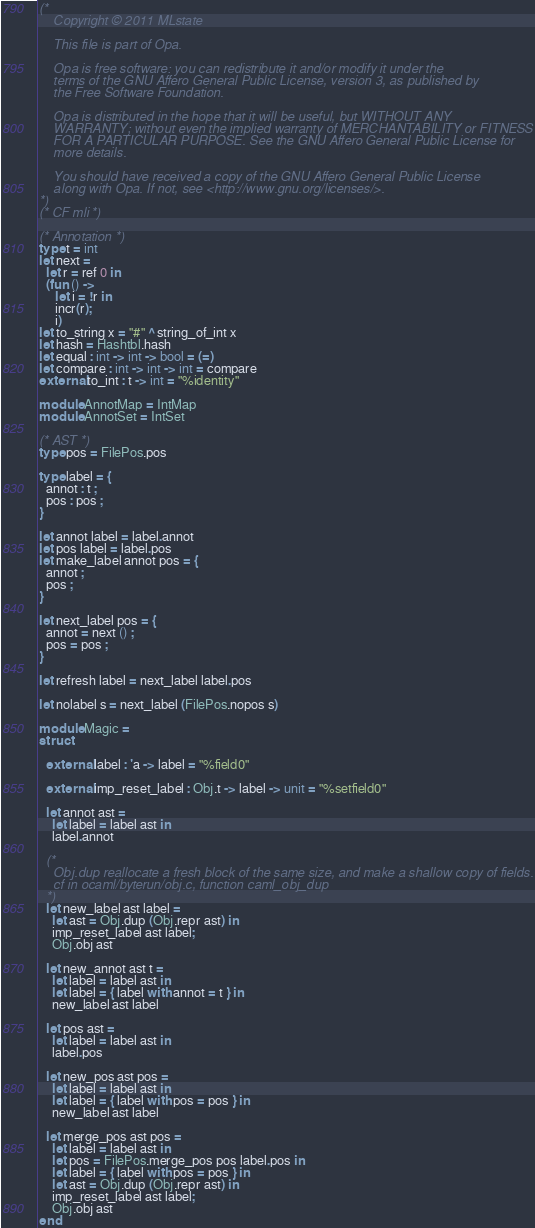<code> <loc_0><loc_0><loc_500><loc_500><_OCaml_>(*
    Copyright © 2011 MLstate

    This file is part of Opa.

    Opa is free software: you can redistribute it and/or modify it under the
    terms of the GNU Affero General Public License, version 3, as published by
    the Free Software Foundation.

    Opa is distributed in the hope that it will be useful, but WITHOUT ANY
    WARRANTY; without even the implied warranty of MERCHANTABILITY or FITNESS
    FOR A PARTICULAR PURPOSE. See the GNU Affero General Public License for
    more details.

    You should have received a copy of the GNU Affero General Public License
    along with Opa. If not, see <http://www.gnu.org/licenses/>.
*)
(* CF mli *)

(* Annotation *)
type t = int
let next =
  let r = ref 0 in
  (fun () ->
     let i = !r in
     incr(r);
     i)
let to_string x = "#" ^ string_of_int x
let hash = Hashtbl.hash
let equal : int -> int -> bool = (=)
let compare : int -> int -> int = compare
external to_int : t -> int = "%identity"

module AnnotMap = IntMap
module AnnotSet = IntSet

(* AST *)
type pos = FilePos.pos

type label = {
  annot : t ;
  pos : pos ;
}

let annot label = label.annot
let pos label = label.pos
let make_label annot pos = {
  annot ;
  pos ;
}

let next_label pos = {
  annot = next () ;
  pos = pos ;
}

let refresh label = next_label label.pos

let nolabel s = next_label (FilePos.nopos s)

module Magic =
struct

  external label : 'a -> label = "%field0"

  external imp_reset_label : Obj.t -> label -> unit = "%setfield0"

  let annot ast =
    let label = label ast in
    label.annot

  (*
    Obj.dup reallocate a fresh block of the same size, and make a shallow copy of fields.
    cf in ocaml/byterun/obj.c, function caml_obj_dup
  *)
  let new_label ast label =
    let ast = Obj.dup (Obj.repr ast) in
    imp_reset_label ast label;
    Obj.obj ast

  let new_annot ast t =
    let label = label ast in
    let label = { label with annot = t } in
    new_label ast label

  let pos ast =
    let label = label ast in
    label.pos

  let new_pos ast pos =
    let label = label ast in
    let label = { label with pos = pos } in
    new_label ast label

  let merge_pos ast pos =
    let label = label ast in
    let pos = FilePos.merge_pos pos label.pos in
    let label = { label with pos = pos } in
    let ast = Obj.dup (Obj.repr ast) in
    imp_reset_label ast label;
    Obj.obj ast
end
</code> 